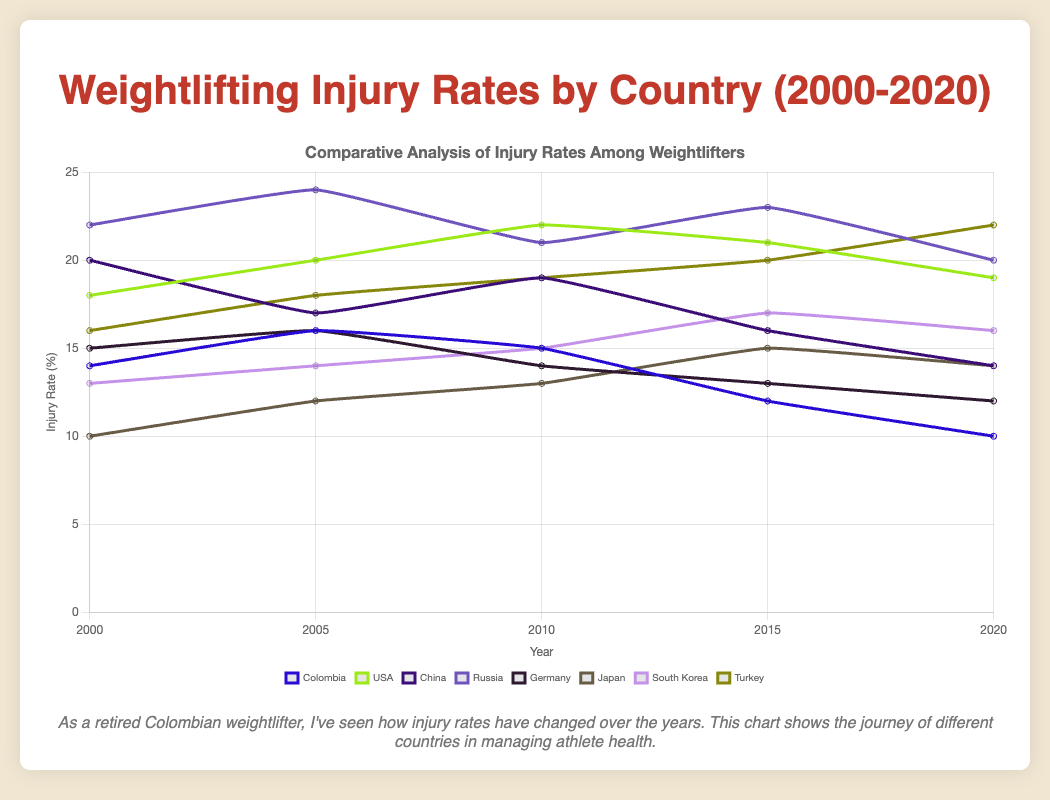What is the trend in injury rates for Colombia from 2000 to 2020? Observe the line representing Colombia. The injury rates decrease over time from a high of 14 in 2000 to a low of 10 in 2020.
Answer: Decreasing Which country had the highest injury rate in 2005? Compare the injury rates for all countries in 2005. Russia had the highest rate with 24.
Answer: Russia Between 2010 and 2015, how did the injury rates for China and Russia change? Observe the rates for China which decreased from 19 to 16 and for Russia which increased from 21 to 23 during this period.
Answer: China decreased, Russia increased What is the average injury rate for Germany from 2000 to 2020? Sum Germany's injury rates for each year (15+16+14+13+12=70) and divide by 5 (years).
Answer: 14 Which country showed the largest decrease in injury rate from 2000 to 2020? Compare each country's difference between 2000 and 2020. China decreased the most from 20 to 14 (a decrease of 6).
Answer: China Compare the trends of injury rates between Japan and South Korea from 2000 to 2020. Look at Japan, which increases from 10 to 14, and South Korea, which increases from 13 to 16. Both show an upward trend.
Answer: Both increased What is the difference in injury rates between Turkey and USA in 2020? Subtract USA's injury rate from Turkey's (22 - 19).
Answer: 3 In which year did Colombia have its lowest injury rate and what was the rate? Identify the year with the lowest rate for Colombia, which is 2020, with a rate of 10.
Answer: 2020, 10 By how much did the injury rate of the USA change from 2000 to 2020? Calculate the difference between the USA's injury rates in 2000 and 2020 (19 - 18).
Answer: 1 How many countries had a decreasing trend in injury rates from 2000 to 2020? Observe the countries' trends over the years. Colombia, China, and Germany had decreasing trends.
Answer: 3 